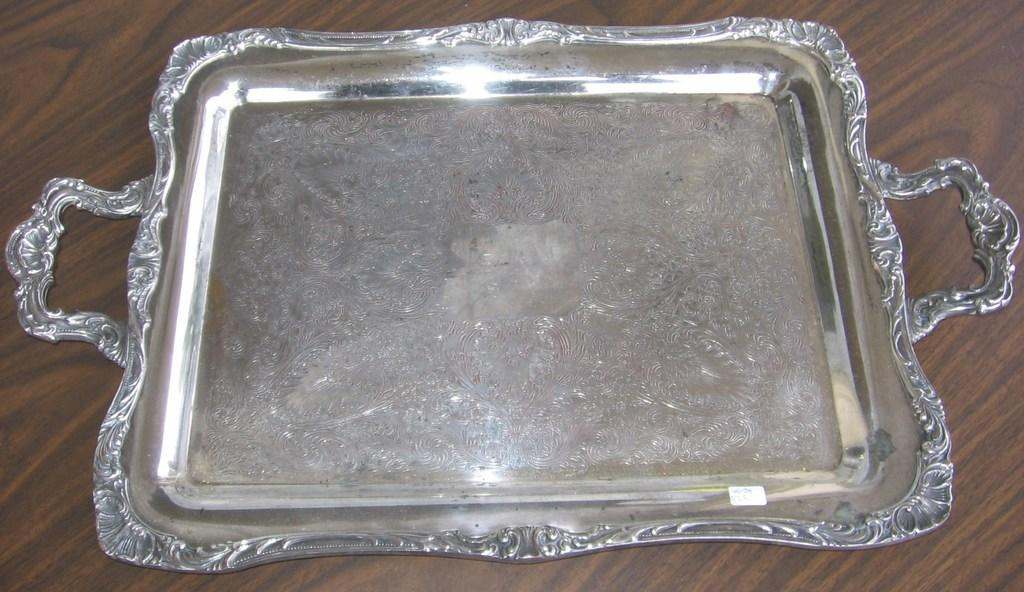What is the main object in the image? There is a silver serving tray in the image. Where is the tray located? The tray is on a table. What type of alley can be seen in the image? There is no alley present in the image; it only features a silver serving tray on a table. What color is the gold ink used in the image? There is no gold ink present in the image, as it only features a silver serving tray on a table. 